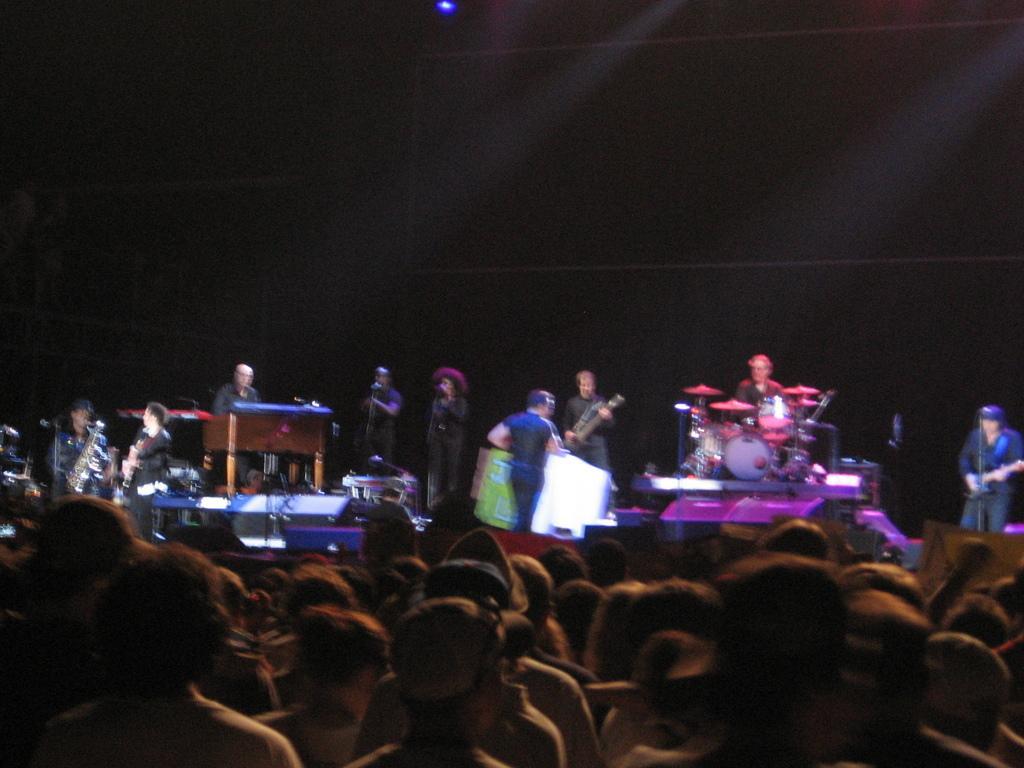In one or two sentences, can you explain what this image depicts? In this image I see number of people in which these people who are on the platform are holding musical instruments in their hands and I see that it is dark over here and I see the light over here. 